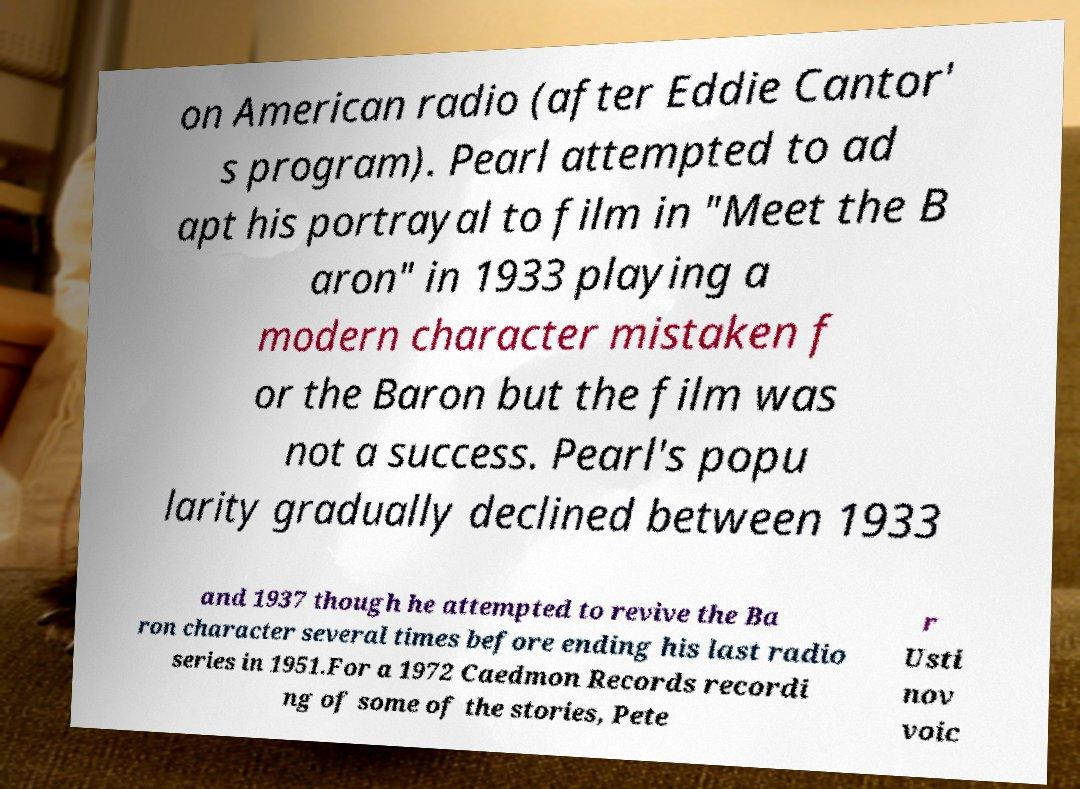Can you read and provide the text displayed in the image?This photo seems to have some interesting text. Can you extract and type it out for me? on American radio (after Eddie Cantor' s program). Pearl attempted to ad apt his portrayal to film in "Meet the B aron" in 1933 playing a modern character mistaken f or the Baron but the film was not a success. Pearl's popu larity gradually declined between 1933 and 1937 though he attempted to revive the Ba ron character several times before ending his last radio series in 1951.For a 1972 Caedmon Records recordi ng of some of the stories, Pete r Usti nov voic 